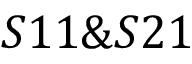Convert formula to latex. <formula><loc_0><loc_0><loc_500><loc_500>S 1 1 \& S 2 1</formula> 